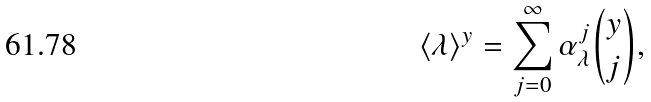Convert formula to latex. <formula><loc_0><loc_0><loc_500><loc_500>\langle \lambda \rangle ^ { y } = \sum _ { j = 0 } ^ { \infty } \alpha _ { \lambda } ^ { j } \binom { y } { j } ,</formula> 